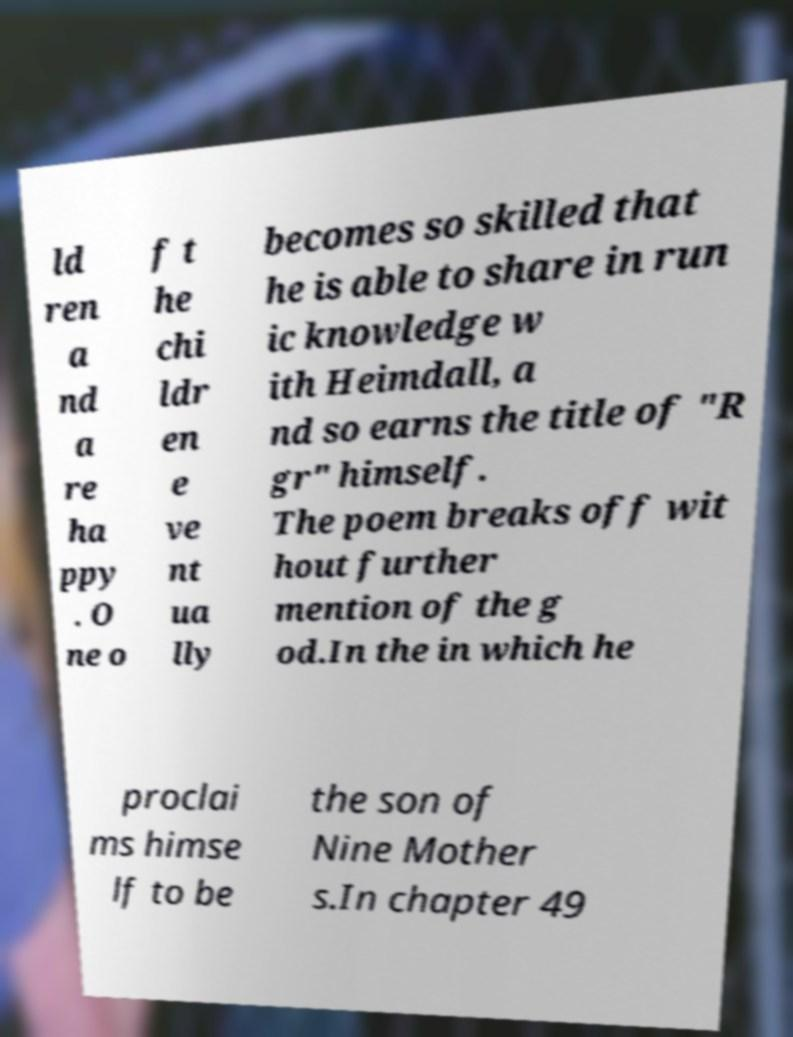For documentation purposes, I need the text within this image transcribed. Could you provide that? ld ren a nd a re ha ppy . O ne o f t he chi ldr en e ve nt ua lly becomes so skilled that he is able to share in run ic knowledge w ith Heimdall, a nd so earns the title of "R gr" himself. The poem breaks off wit hout further mention of the g od.In the in which he proclai ms himse lf to be the son of Nine Mother s.In chapter 49 